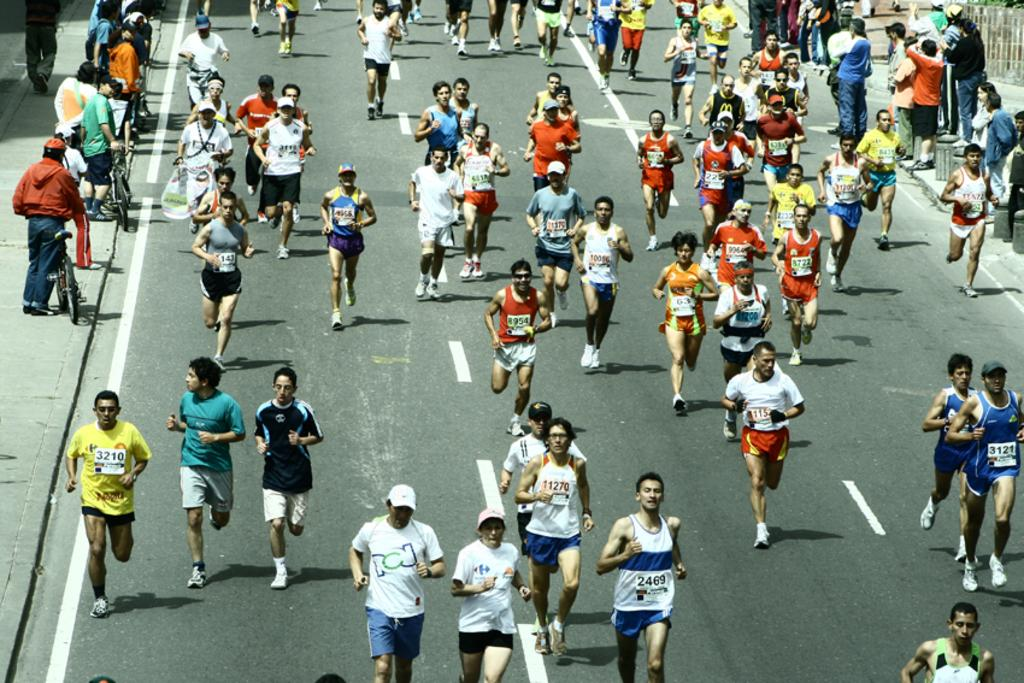What are the people in the image doing? The people in the image are running on the road. Can you describe the background of the image? In the background, there are people standing with their bicycles. What type of eggnog can be seen in the hands of the people running in the image? There is no eggnog present in the image; the people are running without any visible drinks or objects in their hands. 